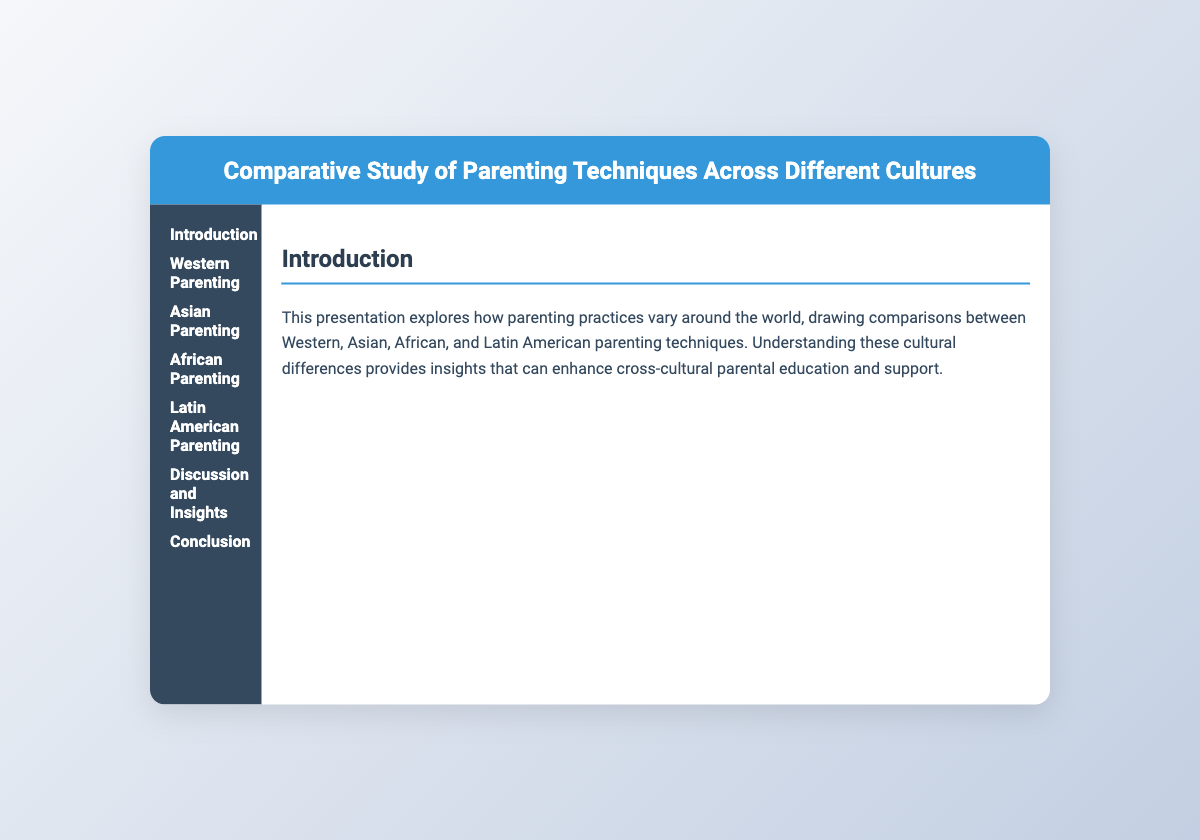what are the four cultures compared in the study? The presentation compares Western, Asian, African, and Latin American parenting techniques.
Answer: Western, Asian, African, Latin American which parenting style is predominant in Western cultures? The presentation states that authoritative parenting is predominant in Western cultures.
Answer: authoritative what concept reflects the intensity of academic and extracurricular demands in Asian parenting? The presentation mentions 'tiger parenting' as reflecting the intensity of academic and extracurricular demands in Asian parenting.
Answer: tiger parenting how do many African cultures approach parenting? The document describes communal parenting as common in many African cultures.
Answer: communal what is emphasized in Latin American parenting according to the presentation? The presentation emphasizes close familial bonds in Latin American parenting.
Answer: close familial bonds what role does the community play in African parenting techniques? The document states that the community plays significant roles in child-rearing in African cultures.
Answer: significant roles what is a key aspect of Western parenting according to the document? The key aspect of Western parenting highlighted is fostering self-reliance.
Answer: fostering self-reliance how does the presentation suggest different cultures can learn from each other? The conclusion suggests that understanding diverse parenting techniques can lead to more inclusive educational frameworks.
Answer: inclusive educational frameworks what type of document is this? The document is a presentation slide focused on parenting techniques across cultures.
Answer: presentation slide 